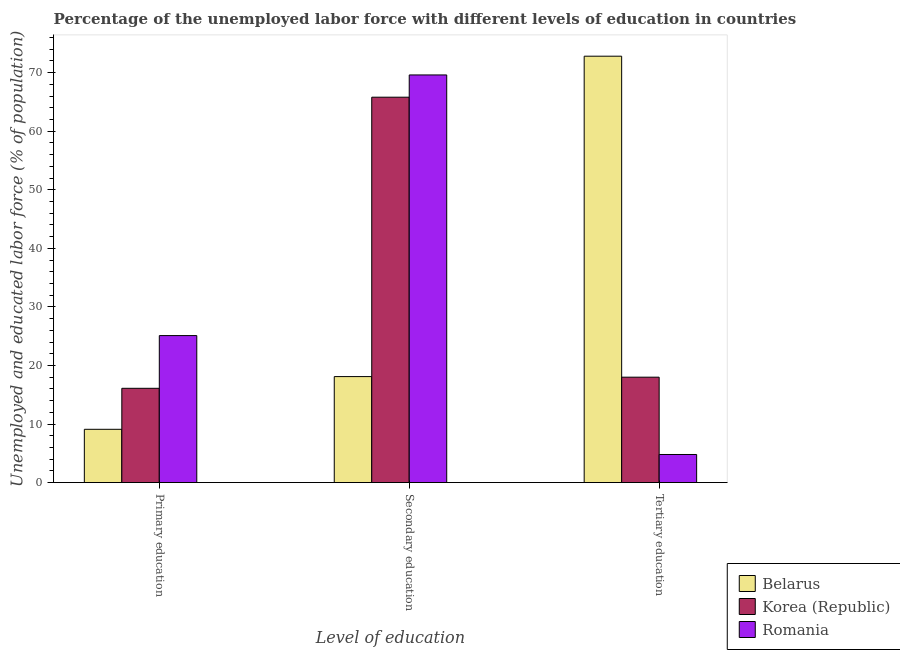Are the number of bars on each tick of the X-axis equal?
Offer a terse response. Yes. How many bars are there on the 1st tick from the left?
Your answer should be compact. 3. What is the label of the 3rd group of bars from the left?
Give a very brief answer. Tertiary education. What is the percentage of labor force who received secondary education in Romania?
Give a very brief answer. 69.6. Across all countries, what is the maximum percentage of labor force who received primary education?
Offer a terse response. 25.1. Across all countries, what is the minimum percentage of labor force who received primary education?
Ensure brevity in your answer.  9.1. In which country was the percentage of labor force who received primary education maximum?
Make the answer very short. Romania. In which country was the percentage of labor force who received primary education minimum?
Offer a very short reply. Belarus. What is the total percentage of labor force who received primary education in the graph?
Keep it short and to the point. 50.3. What is the difference between the percentage of labor force who received primary education in Romania and that in Korea (Republic)?
Your response must be concise. 9. What is the difference between the percentage of labor force who received tertiary education in Romania and the percentage of labor force who received primary education in Belarus?
Offer a terse response. -4.3. What is the average percentage of labor force who received primary education per country?
Provide a short and direct response. 16.77. What is the difference between the percentage of labor force who received tertiary education and percentage of labor force who received secondary education in Romania?
Ensure brevity in your answer.  -64.8. In how many countries, is the percentage of labor force who received secondary education greater than 8 %?
Provide a succinct answer. 3. What is the ratio of the percentage of labor force who received secondary education in Belarus to that in Romania?
Your answer should be compact. 0.26. What is the difference between the highest and the second highest percentage of labor force who received secondary education?
Make the answer very short. 3.8. What is the difference between the highest and the lowest percentage of labor force who received primary education?
Your response must be concise. 16. What does the 3rd bar from the left in Primary education represents?
Make the answer very short. Romania. What does the 2nd bar from the right in Tertiary education represents?
Your answer should be compact. Korea (Republic). How many bars are there?
Make the answer very short. 9. How many countries are there in the graph?
Offer a very short reply. 3. What is the difference between two consecutive major ticks on the Y-axis?
Give a very brief answer. 10. Are the values on the major ticks of Y-axis written in scientific E-notation?
Your answer should be very brief. No. Does the graph contain grids?
Provide a short and direct response. No. What is the title of the graph?
Provide a succinct answer. Percentage of the unemployed labor force with different levels of education in countries. Does "Barbados" appear as one of the legend labels in the graph?
Give a very brief answer. No. What is the label or title of the X-axis?
Your response must be concise. Level of education. What is the label or title of the Y-axis?
Your response must be concise. Unemployed and educated labor force (% of population). What is the Unemployed and educated labor force (% of population) of Belarus in Primary education?
Offer a terse response. 9.1. What is the Unemployed and educated labor force (% of population) in Korea (Republic) in Primary education?
Provide a short and direct response. 16.1. What is the Unemployed and educated labor force (% of population) in Romania in Primary education?
Offer a terse response. 25.1. What is the Unemployed and educated labor force (% of population) in Belarus in Secondary education?
Ensure brevity in your answer.  18.1. What is the Unemployed and educated labor force (% of population) of Korea (Republic) in Secondary education?
Provide a short and direct response. 65.8. What is the Unemployed and educated labor force (% of population) of Romania in Secondary education?
Your answer should be very brief. 69.6. What is the Unemployed and educated labor force (% of population) of Belarus in Tertiary education?
Keep it short and to the point. 72.8. What is the Unemployed and educated labor force (% of population) of Korea (Republic) in Tertiary education?
Make the answer very short. 18. What is the Unemployed and educated labor force (% of population) in Romania in Tertiary education?
Offer a very short reply. 4.8. Across all Level of education, what is the maximum Unemployed and educated labor force (% of population) in Belarus?
Your answer should be compact. 72.8. Across all Level of education, what is the maximum Unemployed and educated labor force (% of population) in Korea (Republic)?
Provide a succinct answer. 65.8. Across all Level of education, what is the maximum Unemployed and educated labor force (% of population) in Romania?
Your answer should be very brief. 69.6. Across all Level of education, what is the minimum Unemployed and educated labor force (% of population) of Belarus?
Ensure brevity in your answer.  9.1. Across all Level of education, what is the minimum Unemployed and educated labor force (% of population) of Korea (Republic)?
Your answer should be very brief. 16.1. Across all Level of education, what is the minimum Unemployed and educated labor force (% of population) of Romania?
Keep it short and to the point. 4.8. What is the total Unemployed and educated labor force (% of population) in Belarus in the graph?
Ensure brevity in your answer.  100. What is the total Unemployed and educated labor force (% of population) in Korea (Republic) in the graph?
Offer a very short reply. 99.9. What is the total Unemployed and educated labor force (% of population) in Romania in the graph?
Your answer should be very brief. 99.5. What is the difference between the Unemployed and educated labor force (% of population) of Korea (Republic) in Primary education and that in Secondary education?
Provide a succinct answer. -49.7. What is the difference between the Unemployed and educated labor force (% of population) in Romania in Primary education and that in Secondary education?
Make the answer very short. -44.5. What is the difference between the Unemployed and educated labor force (% of population) in Belarus in Primary education and that in Tertiary education?
Your response must be concise. -63.7. What is the difference between the Unemployed and educated labor force (% of population) in Romania in Primary education and that in Tertiary education?
Your answer should be compact. 20.3. What is the difference between the Unemployed and educated labor force (% of population) of Belarus in Secondary education and that in Tertiary education?
Offer a terse response. -54.7. What is the difference between the Unemployed and educated labor force (% of population) in Korea (Republic) in Secondary education and that in Tertiary education?
Offer a very short reply. 47.8. What is the difference between the Unemployed and educated labor force (% of population) of Romania in Secondary education and that in Tertiary education?
Your response must be concise. 64.8. What is the difference between the Unemployed and educated labor force (% of population) in Belarus in Primary education and the Unemployed and educated labor force (% of population) in Korea (Republic) in Secondary education?
Keep it short and to the point. -56.7. What is the difference between the Unemployed and educated labor force (% of population) in Belarus in Primary education and the Unemployed and educated labor force (% of population) in Romania in Secondary education?
Provide a succinct answer. -60.5. What is the difference between the Unemployed and educated labor force (% of population) in Korea (Republic) in Primary education and the Unemployed and educated labor force (% of population) in Romania in Secondary education?
Keep it short and to the point. -53.5. What is the difference between the Unemployed and educated labor force (% of population) in Belarus in Primary education and the Unemployed and educated labor force (% of population) in Korea (Republic) in Tertiary education?
Offer a very short reply. -8.9. What is the difference between the Unemployed and educated labor force (% of population) of Belarus in Secondary education and the Unemployed and educated labor force (% of population) of Romania in Tertiary education?
Offer a terse response. 13.3. What is the difference between the Unemployed and educated labor force (% of population) of Korea (Republic) in Secondary education and the Unemployed and educated labor force (% of population) of Romania in Tertiary education?
Your answer should be very brief. 61. What is the average Unemployed and educated labor force (% of population) in Belarus per Level of education?
Provide a short and direct response. 33.33. What is the average Unemployed and educated labor force (% of population) in Korea (Republic) per Level of education?
Provide a short and direct response. 33.3. What is the average Unemployed and educated labor force (% of population) in Romania per Level of education?
Ensure brevity in your answer.  33.17. What is the difference between the Unemployed and educated labor force (% of population) in Belarus and Unemployed and educated labor force (% of population) in Romania in Primary education?
Provide a succinct answer. -16. What is the difference between the Unemployed and educated labor force (% of population) of Belarus and Unemployed and educated labor force (% of population) of Korea (Republic) in Secondary education?
Provide a succinct answer. -47.7. What is the difference between the Unemployed and educated labor force (% of population) in Belarus and Unemployed and educated labor force (% of population) in Romania in Secondary education?
Offer a terse response. -51.5. What is the difference between the Unemployed and educated labor force (% of population) of Belarus and Unemployed and educated labor force (% of population) of Korea (Republic) in Tertiary education?
Provide a short and direct response. 54.8. What is the difference between the Unemployed and educated labor force (% of population) of Belarus and Unemployed and educated labor force (% of population) of Romania in Tertiary education?
Your answer should be very brief. 68. What is the ratio of the Unemployed and educated labor force (% of population) of Belarus in Primary education to that in Secondary education?
Offer a terse response. 0.5. What is the ratio of the Unemployed and educated labor force (% of population) of Korea (Republic) in Primary education to that in Secondary education?
Make the answer very short. 0.24. What is the ratio of the Unemployed and educated labor force (% of population) in Romania in Primary education to that in Secondary education?
Provide a succinct answer. 0.36. What is the ratio of the Unemployed and educated labor force (% of population) in Belarus in Primary education to that in Tertiary education?
Give a very brief answer. 0.12. What is the ratio of the Unemployed and educated labor force (% of population) of Korea (Republic) in Primary education to that in Tertiary education?
Your answer should be very brief. 0.89. What is the ratio of the Unemployed and educated labor force (% of population) in Romania in Primary education to that in Tertiary education?
Give a very brief answer. 5.23. What is the ratio of the Unemployed and educated labor force (% of population) in Belarus in Secondary education to that in Tertiary education?
Provide a succinct answer. 0.25. What is the ratio of the Unemployed and educated labor force (% of population) of Korea (Republic) in Secondary education to that in Tertiary education?
Keep it short and to the point. 3.66. What is the difference between the highest and the second highest Unemployed and educated labor force (% of population) of Belarus?
Your answer should be compact. 54.7. What is the difference between the highest and the second highest Unemployed and educated labor force (% of population) of Korea (Republic)?
Offer a terse response. 47.8. What is the difference between the highest and the second highest Unemployed and educated labor force (% of population) in Romania?
Ensure brevity in your answer.  44.5. What is the difference between the highest and the lowest Unemployed and educated labor force (% of population) in Belarus?
Your answer should be compact. 63.7. What is the difference between the highest and the lowest Unemployed and educated labor force (% of population) of Korea (Republic)?
Provide a succinct answer. 49.7. What is the difference between the highest and the lowest Unemployed and educated labor force (% of population) in Romania?
Your response must be concise. 64.8. 